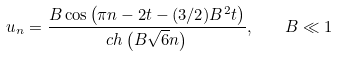<formula> <loc_0><loc_0><loc_500><loc_500>u _ { n } = \frac { B \cos \left ( \pi n - 2 t - ( 3 / 2 ) B ^ { 2 } t \right ) } { c h \left ( B \sqrt { 6 } n \right ) } , \quad B \ll 1</formula> 